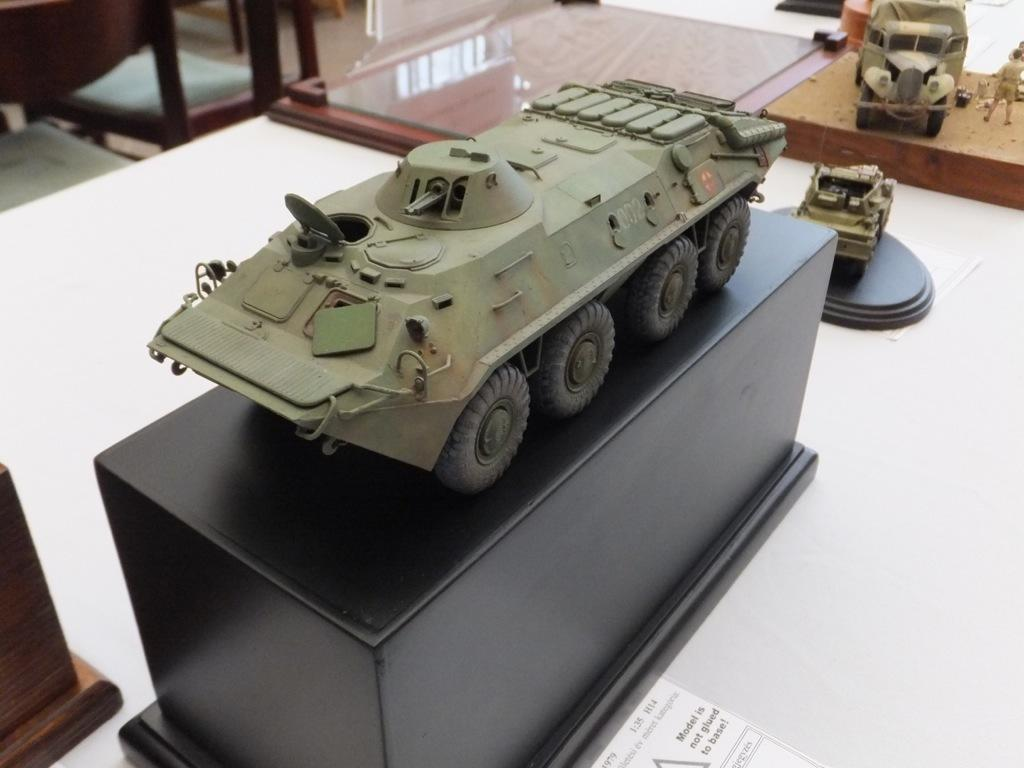What type of vehicle structure is in the image? There is an army tanker vehicle structure in the image. Where is the vehicle structure placed? The vehicle structure is placed on a table. What is under the table in the image? There is a black color box underneath the vehicle structure. What other toy vehicles are in the image? There is a toy jeep and a toy car in the image. How are the toy jeep and car positioned? Both the toy jeep and car are placed on a board. What type of mint is being used to clean the toy jeep in the image? There is no mint present in the image, and the toy jeep is not being cleaned. Is there a maid in the image assisting with the arrangement of the toy vehicles? There is no maid present in the image, and the toy vehicles are not being arranged by anyone. 